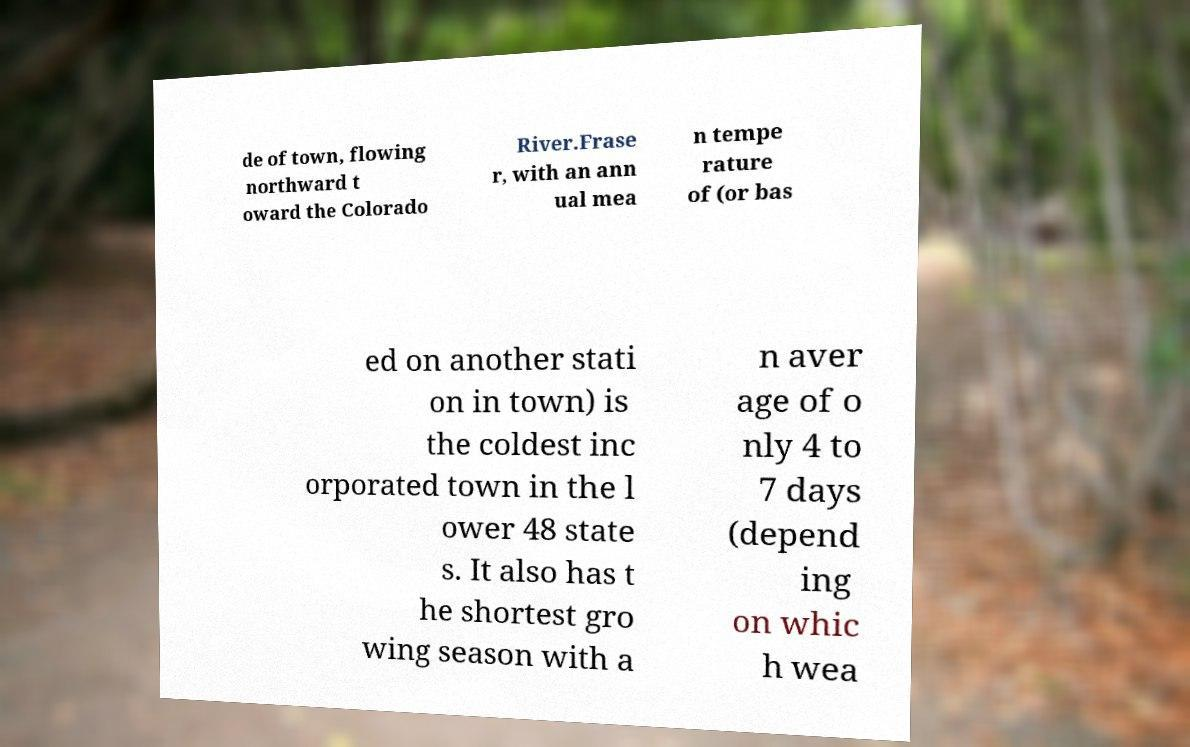Please read and relay the text visible in this image. What does it say? de of town, flowing northward t oward the Colorado River.Frase r, with an ann ual mea n tempe rature of (or bas ed on another stati on in town) is the coldest inc orporated town in the l ower 48 state s. It also has t he shortest gro wing season with a n aver age of o nly 4 to 7 days (depend ing on whic h wea 